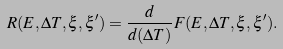<formula> <loc_0><loc_0><loc_500><loc_500>R ( E , \Delta T , \xi , \xi ^ { \prime } ) = \frac { d } { d ( \Delta T ) } F ( E , \Delta T , \xi , \xi ^ { \prime } ) .</formula> 